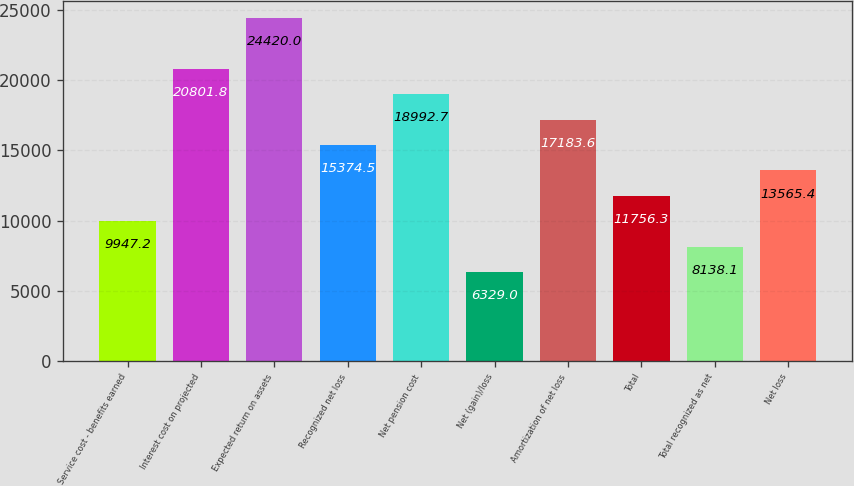<chart> <loc_0><loc_0><loc_500><loc_500><bar_chart><fcel>Service cost - benefits earned<fcel>Interest cost on projected<fcel>Expected return on assets<fcel>Recognized net loss<fcel>Net pension cost<fcel>Net (gain)/loss<fcel>Amortization of net loss<fcel>Total<fcel>Total recognized as net<fcel>Net loss<nl><fcel>9947.2<fcel>20801.8<fcel>24420<fcel>15374.5<fcel>18992.7<fcel>6329<fcel>17183.6<fcel>11756.3<fcel>8138.1<fcel>13565.4<nl></chart> 